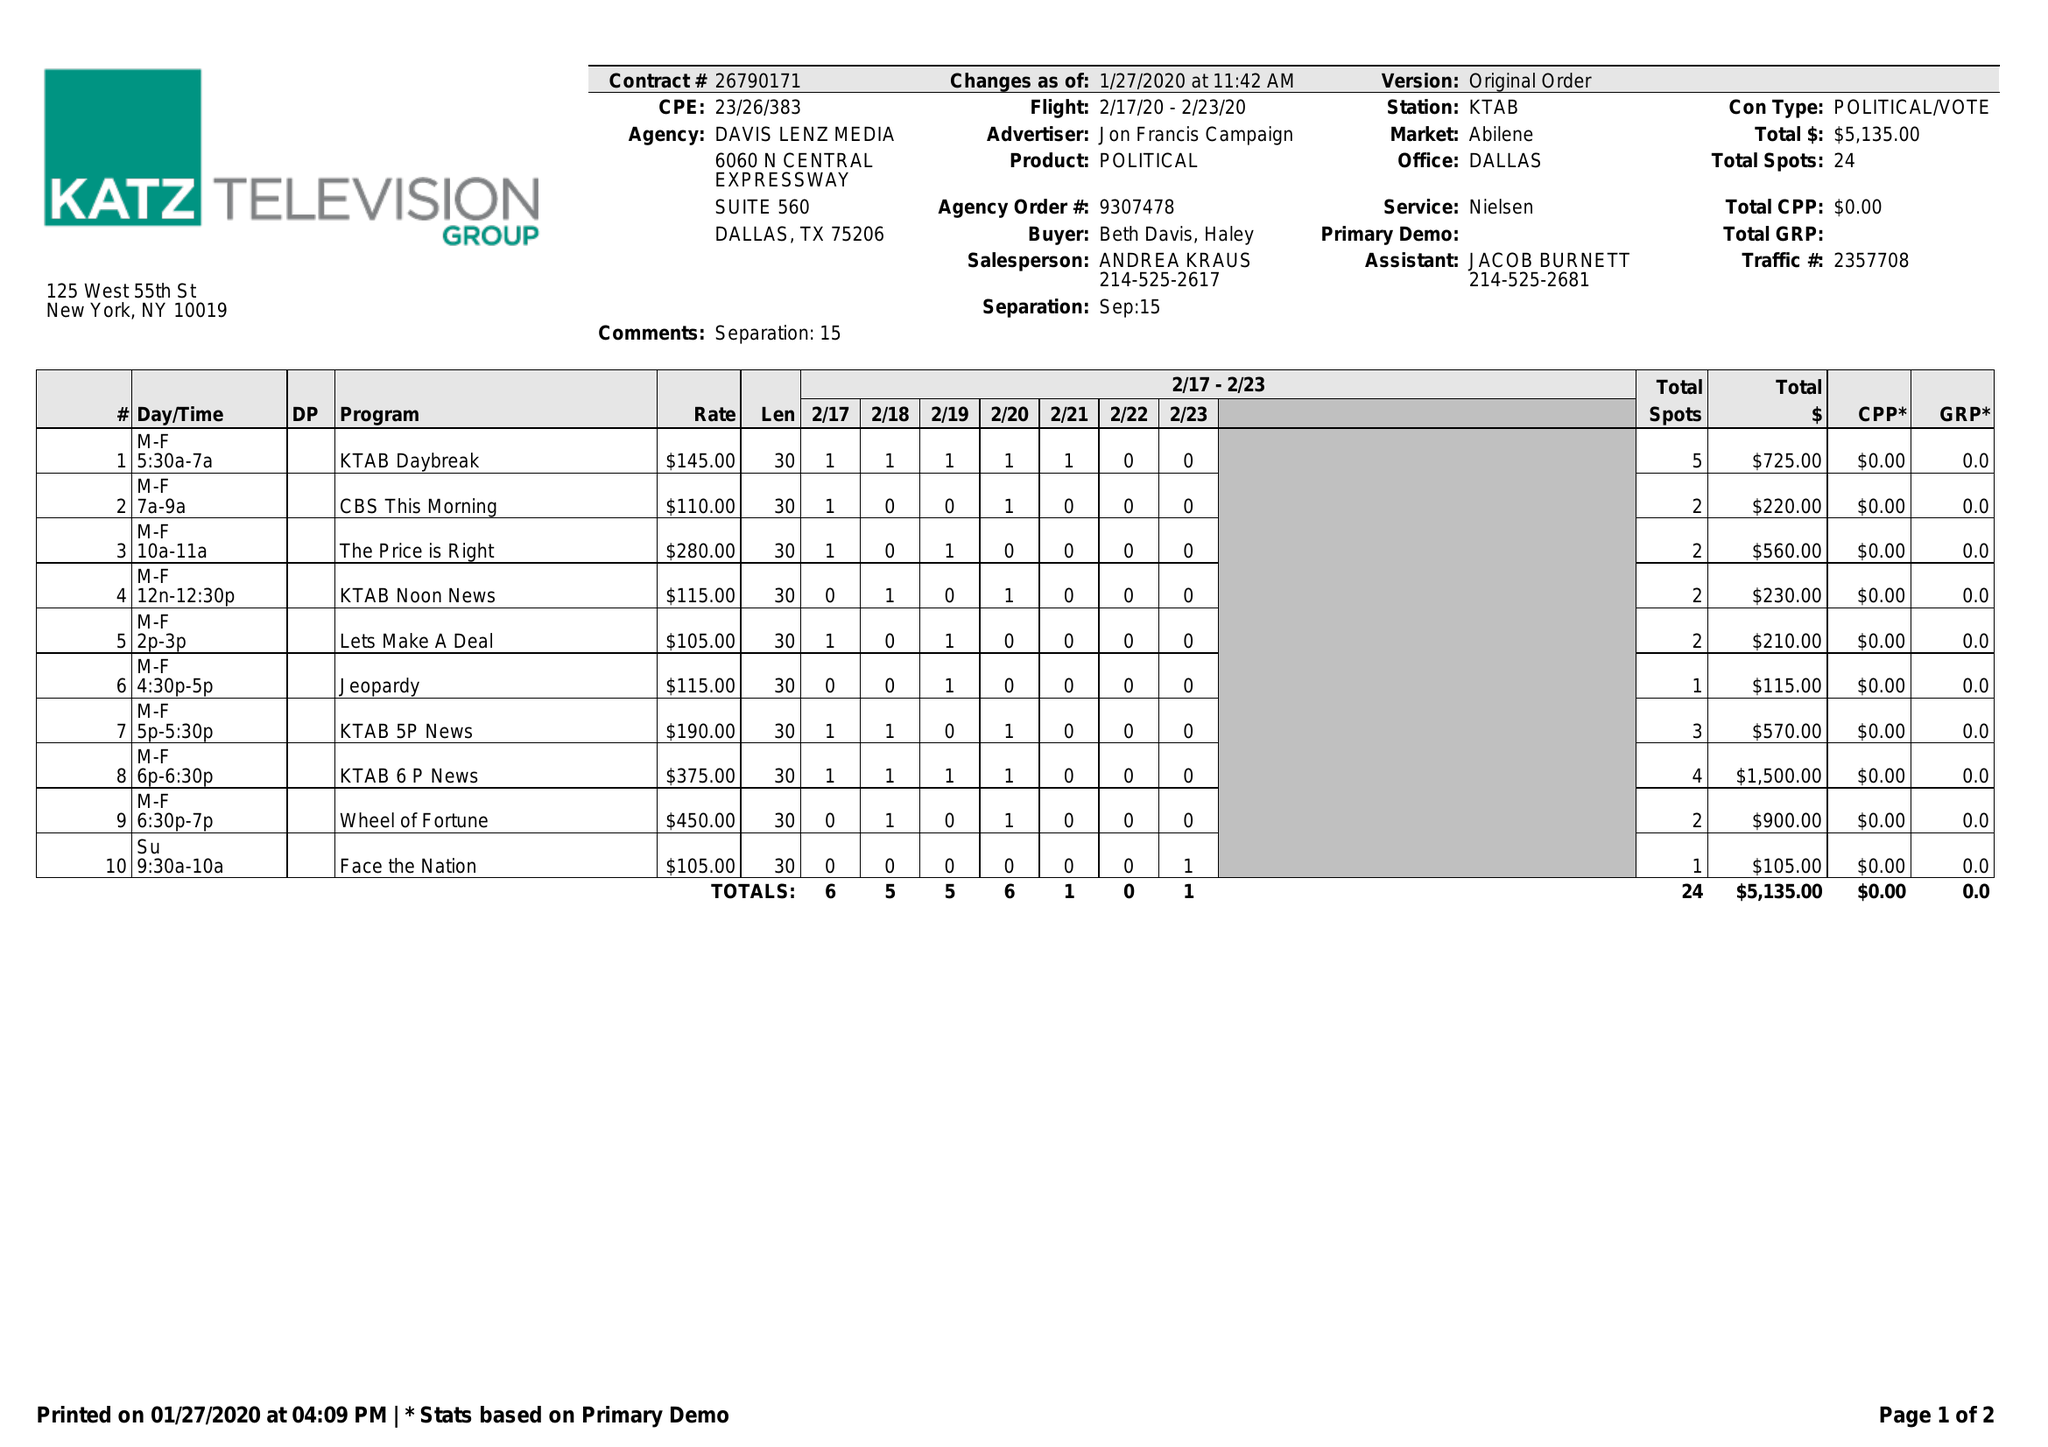What is the value for the advertiser?
Answer the question using a single word or phrase. JON FRANCIS CAMPAIGN 